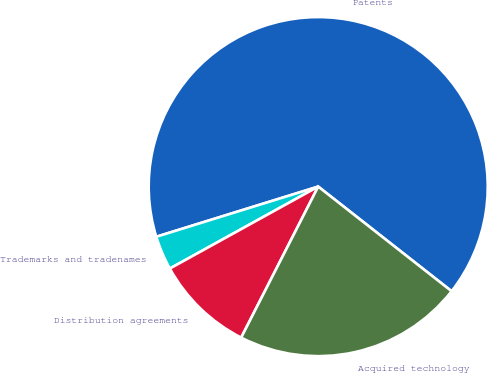<chart> <loc_0><loc_0><loc_500><loc_500><pie_chart><fcel>Patents<fcel>Trademarks and tradenames<fcel>Distribution agreements<fcel>Acquired technology<nl><fcel>65.36%<fcel>3.25%<fcel>9.46%<fcel>21.92%<nl></chart> 